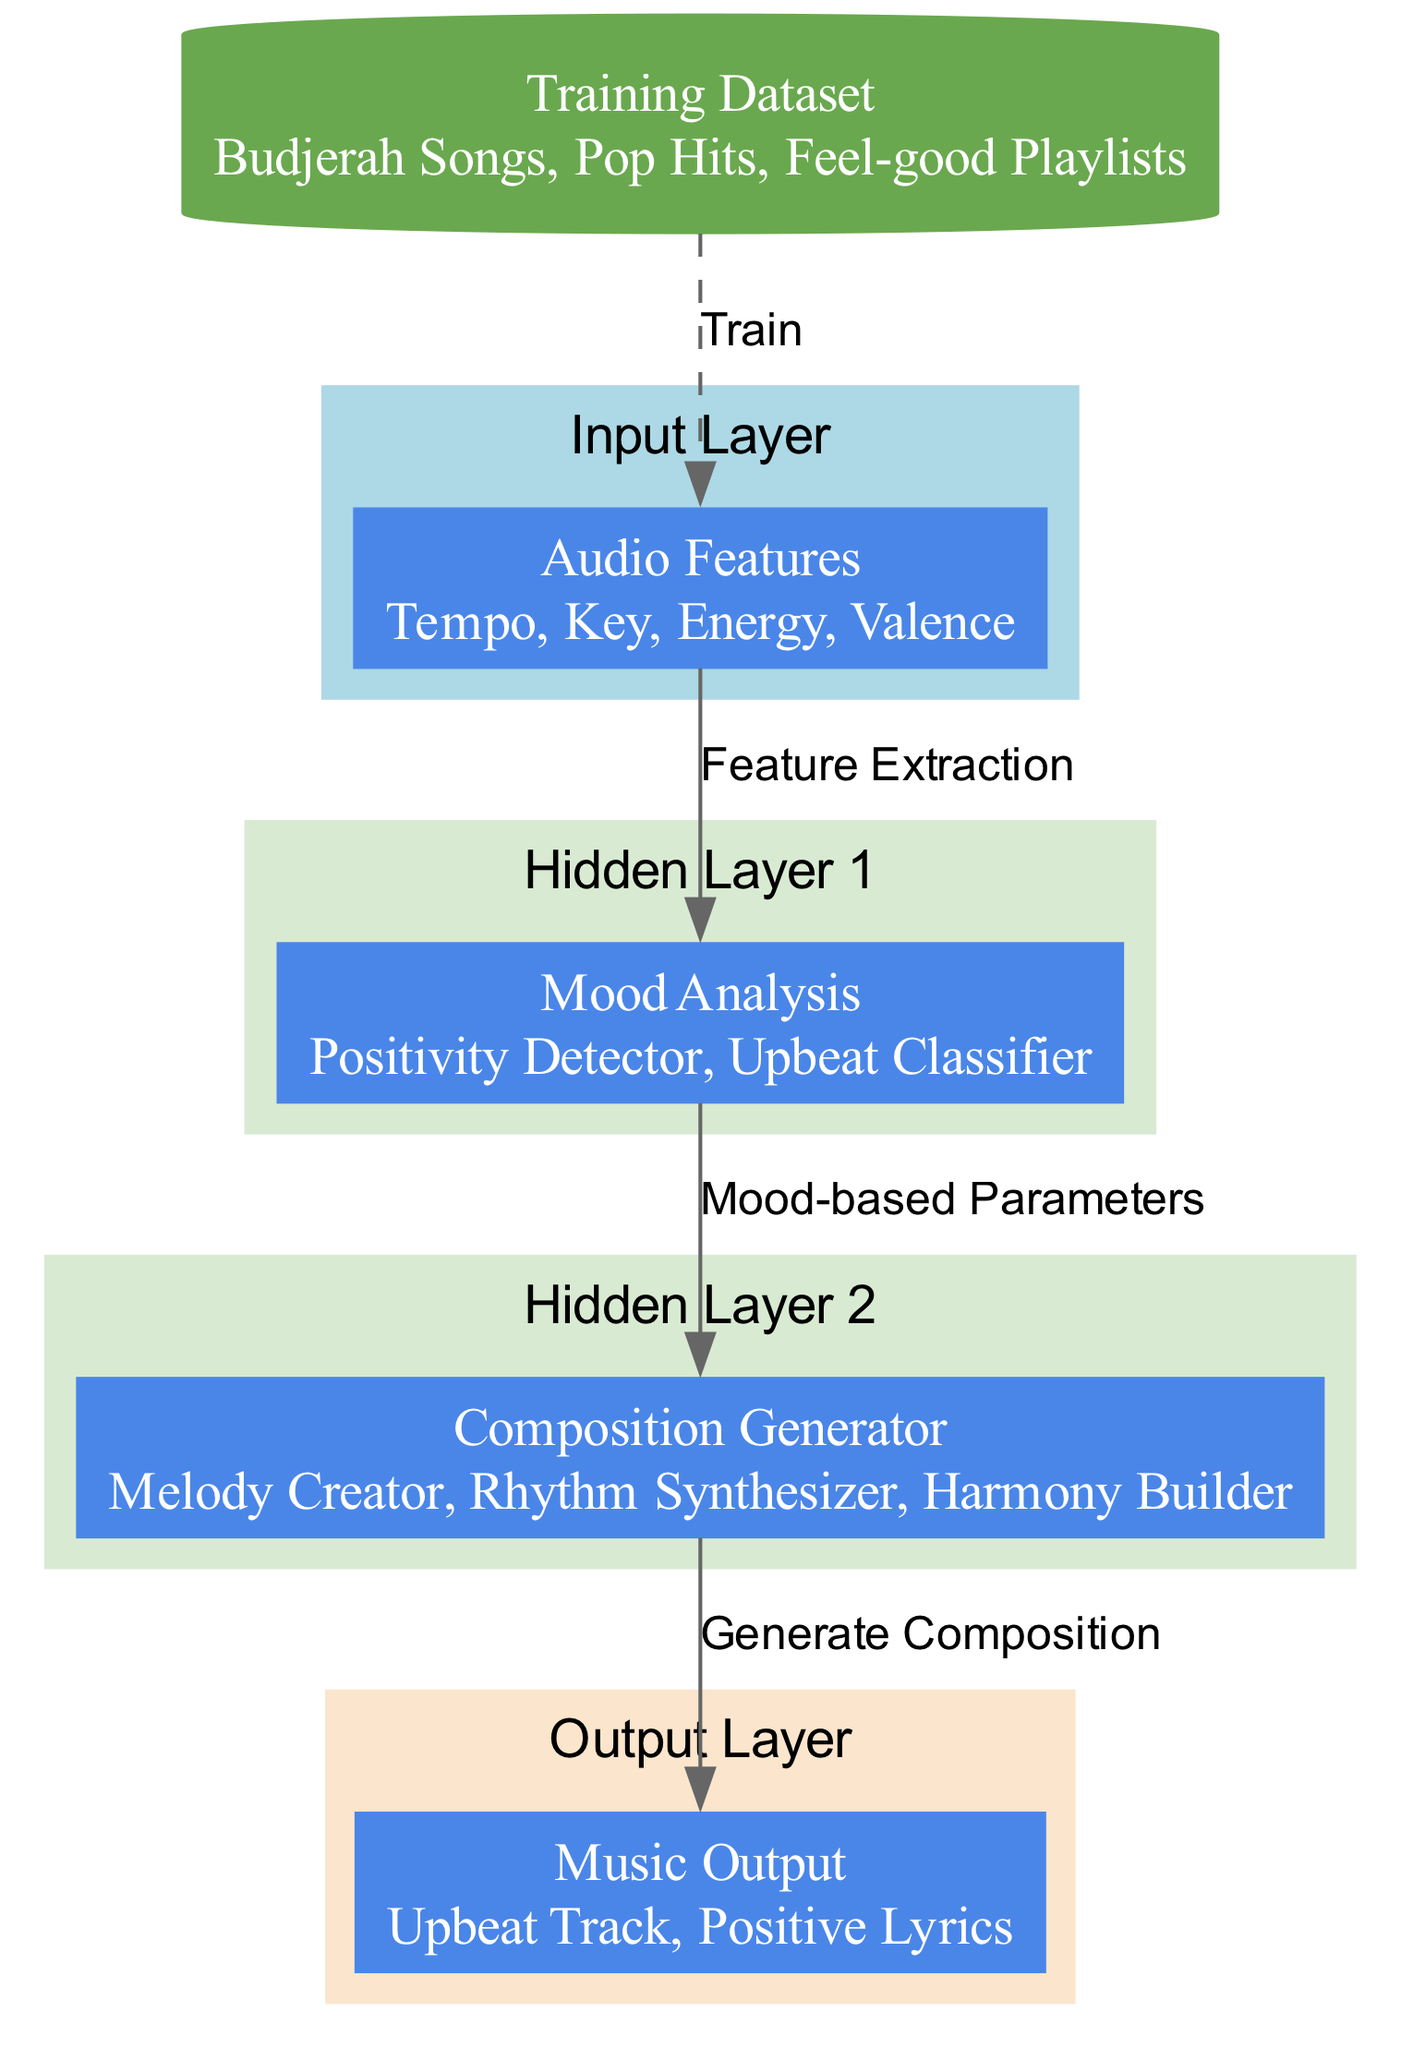What is the main purpose of the "Music Output" node? The "Music Output" node is designed to provide the final output of the neural network, which includes elements that contribute to creating an upbeat musical composition, specifically an upbeat track and positive lyrics.
Answer: Upbeat Track, Positive Lyrics What elements are included in the "Audio Features" node? The "Audio Features" node contains essential elements that serve as input for the neural network, including tempo, key, energy, and valence, which are vital for understanding the musical context.
Answer: Tempo, Key, Energy, Valence How many hidden layers are present in the diagram? The diagram features two hidden layers, each with specific functionalities related to mood analysis and composition generation.
Answer: 2 What are the elements in the "Composition Generator" layer? The "Composition Generator" layer comprises three key elements: the melody creator, the rhythm synthesizer, and the harmony builder, which together help craft the final music composition.
Answer: Melody Creator, Rhythm Synthesizer, Harmony Builder What is the connection label between the "Mood Analysis" and "Composition Generator" nodes? The connection label indicates the flow of information from the "Mood Analysis" to the "Composition Generator," signifying that mood-based parameters are used to influence music composition.
Answer: Mood-based Parameters Which node is receiving the training data? The "Audio Features" node is directly linked to the training data, which consists of Budjerah songs, pop hits, and feel-good playlists, used to train the model for music generation.
Answer: Audio Features What style of music does the training dataset focus on? The training dataset focuses on upbeat and positive music styles, as indicated by the inclusion of Budjerah songs and feel-good playlists that aim to generate similar compositions.
Answer: Upbeat and Positive Music What type of nodes are used in the hidden layers? The hidden layers utilize rectangular nodes to represent different functionalities in the architecture, emphasizing the operational roles of mood analysis and music composition.
Answer: Rectangular Nodes How does the "Training Data" connect to the "Audio Features" layer? The "Training Data" connects to the "Audio Features" layer with a dashed line, indicating that the training data is used to inform and fine-tune the input features for the model.
Answer: Dashed Line 